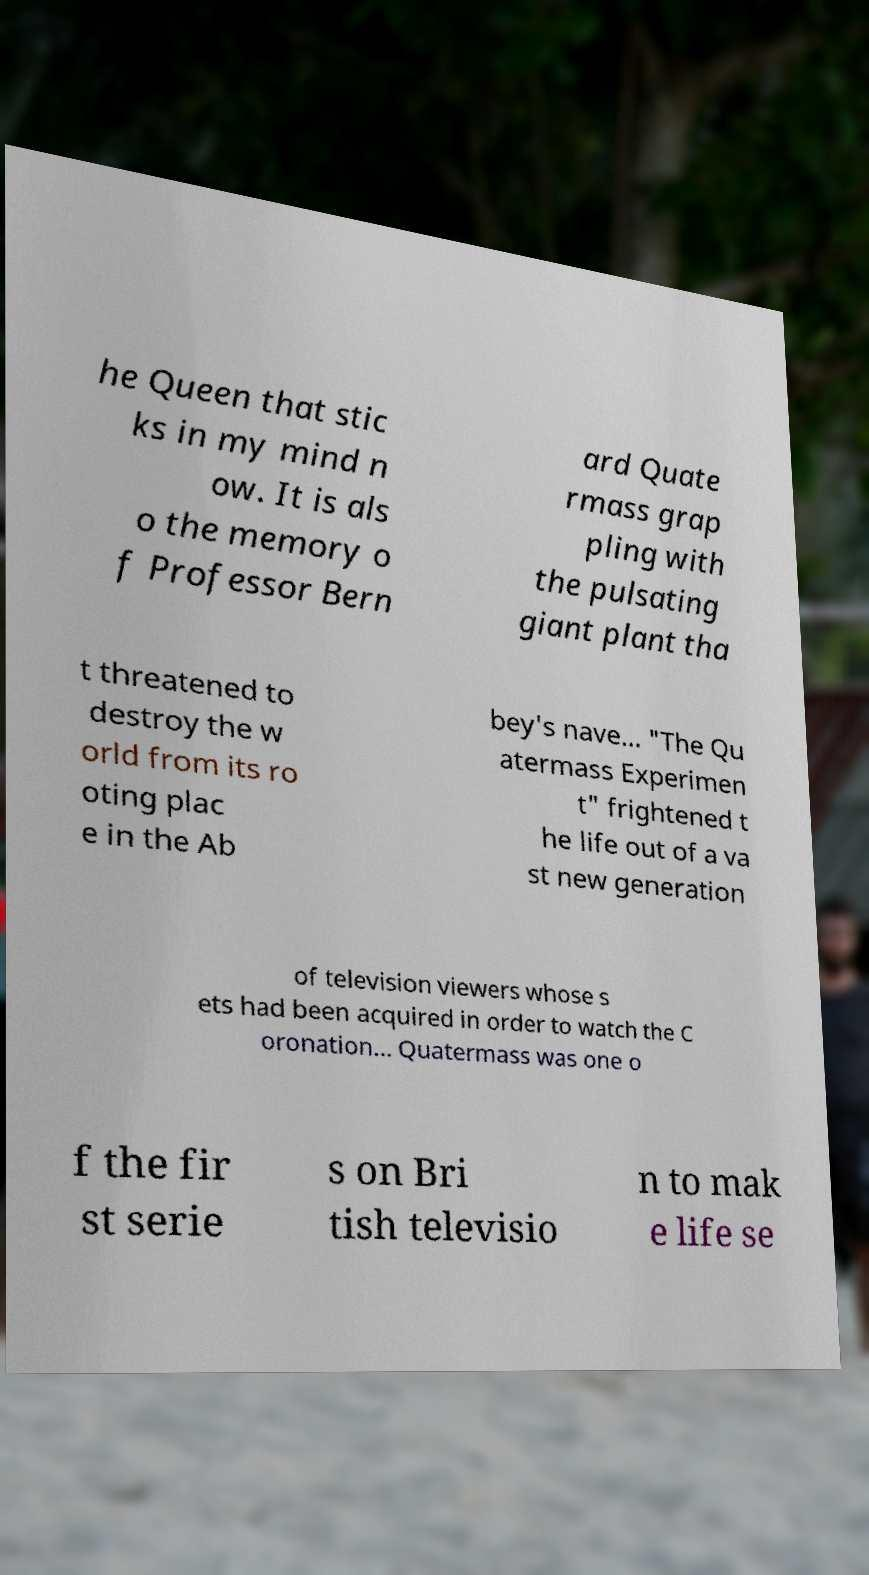What messages or text are displayed in this image? I need them in a readable, typed format. he Queen that stic ks in my mind n ow. It is als o the memory o f Professor Bern ard Quate rmass grap pling with the pulsating giant plant tha t threatened to destroy the w orld from its ro oting plac e in the Ab bey's nave… "The Qu atermass Experimen t" frightened t he life out of a va st new generation of television viewers whose s ets had been acquired in order to watch the C oronation… Quatermass was one o f the fir st serie s on Bri tish televisio n to mak e life se 